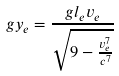<formula> <loc_0><loc_0><loc_500><loc_500>g y _ { e } = \frac { g l _ { e } v _ { e } } { \sqrt { 9 - \frac { v _ { e } ^ { 7 } } { c ^ { 7 } } } }</formula> 